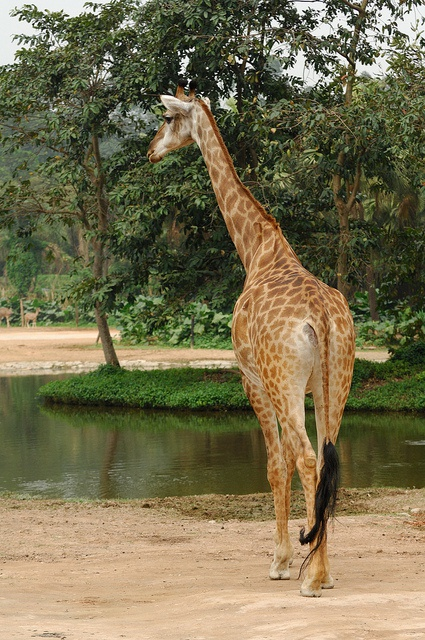Describe the objects in this image and their specific colors. I can see a giraffe in white, tan, brown, and gray tones in this image. 